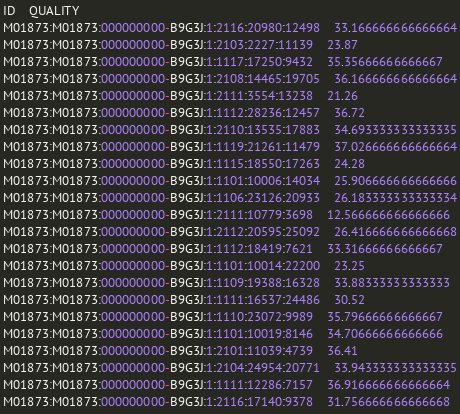<code> <loc_0><loc_0><loc_500><loc_500><_SQL_>ID	QUALITY
M01873:M01873:000000000-B9G3J:1:2116:20980:12498	33.166666666666664
M01873:M01873:000000000-B9G3J:1:2103:2227:11139	23.87
M01873:M01873:000000000-B9G3J:1:1117:17250:9432	35.35666666666667
M01873:M01873:000000000-B9G3J:1:2108:14465:19705	36.166666666666664
M01873:M01873:000000000-B9G3J:1:2111:3554:13238	21.26
M01873:M01873:000000000-B9G3J:1:1112:28236:12457	36.72
M01873:M01873:000000000-B9G3J:1:2110:13535:17883	34.693333333333335
M01873:M01873:000000000-B9G3J:1:1119:21261:11479	37.026666666666664
M01873:M01873:000000000-B9G3J:1:1115:18550:17263	24.28
M01873:M01873:000000000-B9G3J:1:1101:10006:14034	25.906666666666666
M01873:M01873:000000000-B9G3J:1:1106:23126:20933	26.183333333333334
M01873:M01873:000000000-B9G3J:1:2111:10779:3698	12.566666666666666
M01873:M01873:000000000-B9G3J:1:2112:20595:25092	26.416666666666668
M01873:M01873:000000000-B9G3J:1:1112:18419:7621	33.31666666666667
M01873:M01873:000000000-B9G3J:1:1101:10014:22200	23.25
M01873:M01873:000000000-B9G3J:1:1109:19388:16328	33.88333333333333
M01873:M01873:000000000-B9G3J:1:1111:16537:24486	30.52
M01873:M01873:000000000-B9G3J:1:1110:23072:9989	35.79666666666667
M01873:M01873:000000000-B9G3J:1:1101:10019:8146	34.70666666666666
M01873:M01873:000000000-B9G3J:1:2101:11039:4739	36.41
M01873:M01873:000000000-B9G3J:1:2104:24954:20771	33.943333333333335
M01873:M01873:000000000-B9G3J:1:1111:12286:7157	36.916666666666664
M01873:M01873:000000000-B9G3J:1:2116:17140:9378	31.756666666666668</code> 